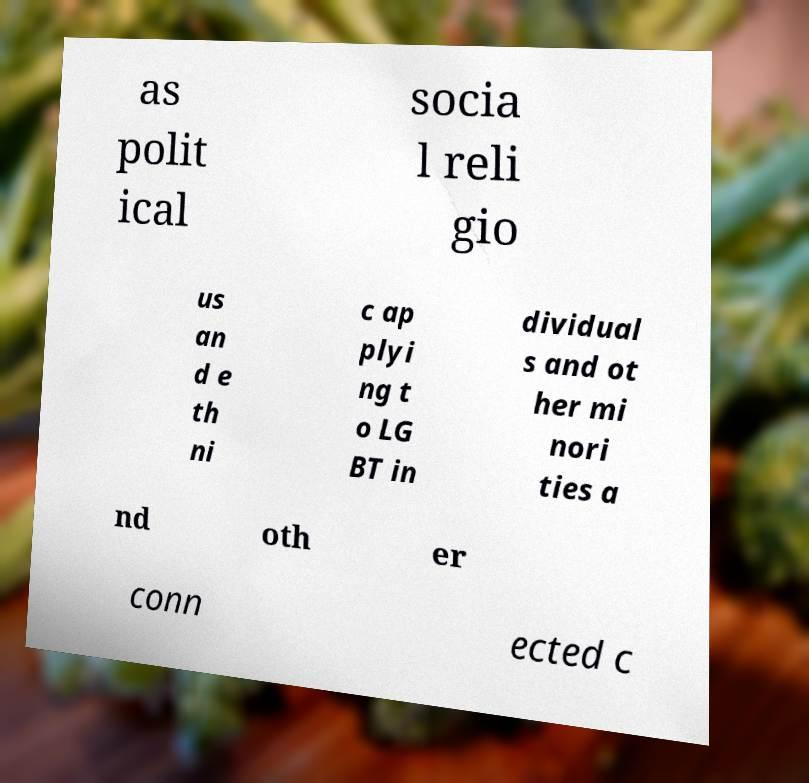There's text embedded in this image that I need extracted. Can you transcribe it verbatim? as polit ical socia l reli gio us an d e th ni c ap plyi ng t o LG BT in dividual s and ot her mi nori ties a nd oth er conn ected c 